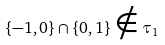<formula> <loc_0><loc_0><loc_500><loc_500>\{ - 1 , 0 \} \cap \{ 0 , 1 \} \notin \tau _ { 1 }</formula> 